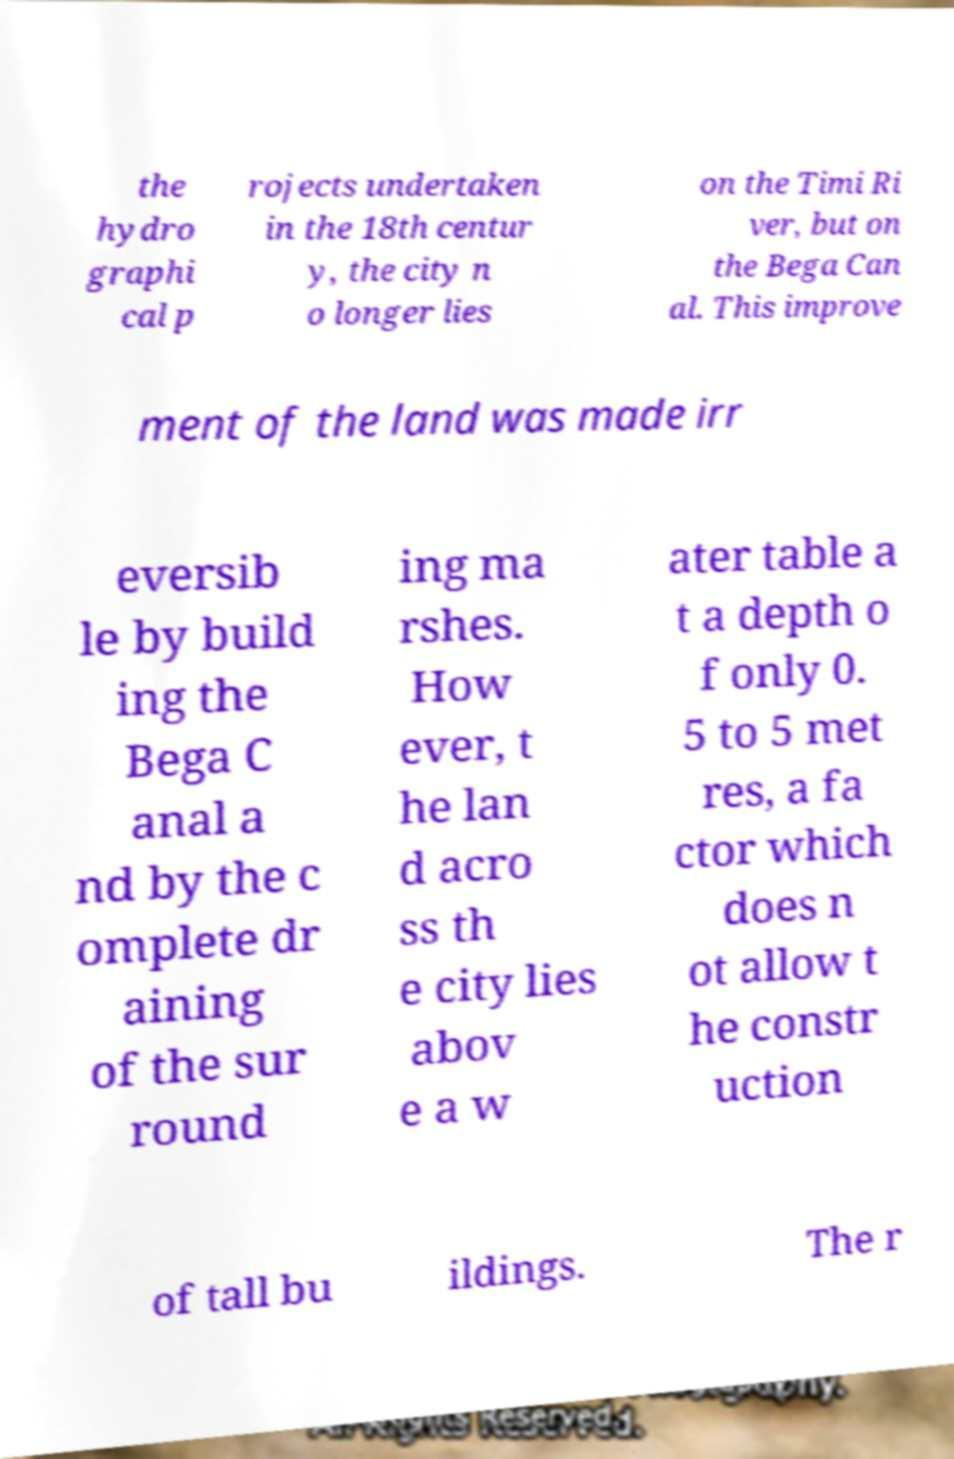What messages or text are displayed in this image? I need them in a readable, typed format. the hydro graphi cal p rojects undertaken in the 18th centur y, the city n o longer lies on the Timi Ri ver, but on the Bega Can al. This improve ment of the land was made irr eversib le by build ing the Bega C anal a nd by the c omplete dr aining of the sur round ing ma rshes. How ever, t he lan d acro ss th e city lies abov e a w ater table a t a depth o f only 0. 5 to 5 met res, a fa ctor which does n ot allow t he constr uction of tall bu ildings. The r 